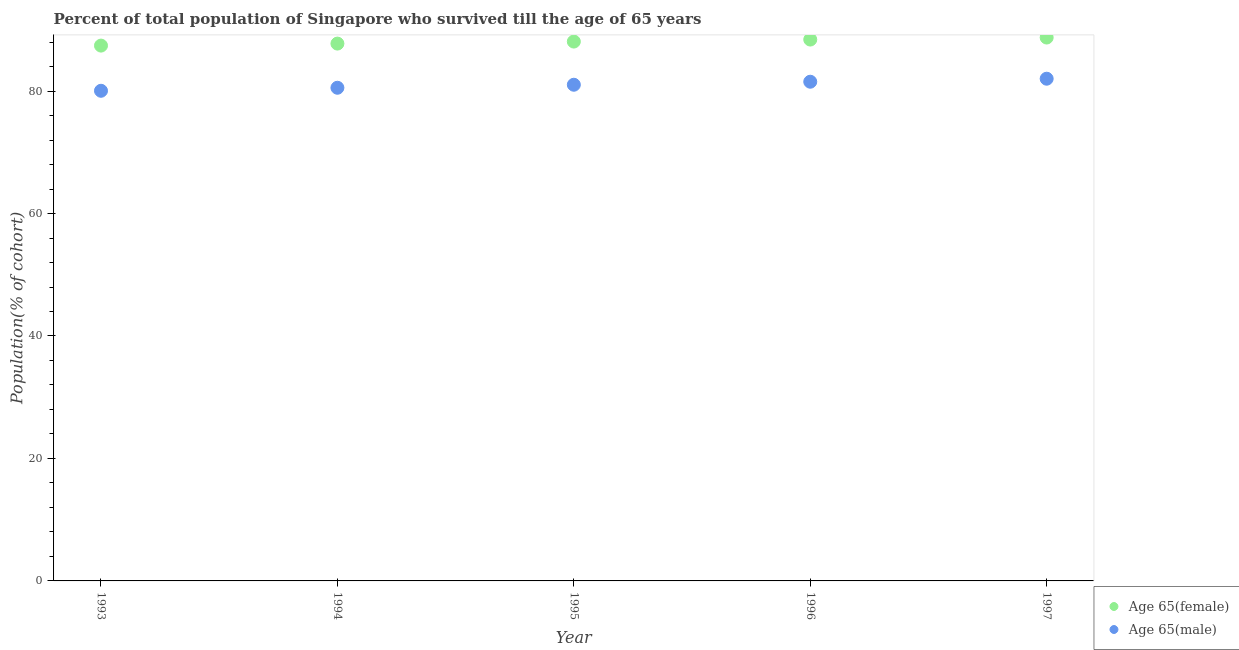How many different coloured dotlines are there?
Make the answer very short. 2. Is the number of dotlines equal to the number of legend labels?
Your answer should be compact. Yes. What is the percentage of female population who survived till age of 65 in 1993?
Offer a very short reply. 87.42. Across all years, what is the maximum percentage of male population who survived till age of 65?
Ensure brevity in your answer.  82.02. Across all years, what is the minimum percentage of male population who survived till age of 65?
Your response must be concise. 80.05. What is the total percentage of male population who survived till age of 65 in the graph?
Provide a short and direct response. 405.16. What is the difference between the percentage of female population who survived till age of 65 in 1996 and that in 1997?
Make the answer very short. -0.33. What is the difference between the percentage of female population who survived till age of 65 in 1997 and the percentage of male population who survived till age of 65 in 1996?
Give a very brief answer. 7.22. What is the average percentage of male population who survived till age of 65 per year?
Provide a succinct answer. 81.03. In the year 1993, what is the difference between the percentage of male population who survived till age of 65 and percentage of female population who survived till age of 65?
Keep it short and to the point. -7.38. What is the ratio of the percentage of male population who survived till age of 65 in 1995 to that in 1997?
Make the answer very short. 0.99. Is the difference between the percentage of female population who survived till age of 65 in 1993 and 1997 greater than the difference between the percentage of male population who survived till age of 65 in 1993 and 1997?
Keep it short and to the point. Yes. What is the difference between the highest and the second highest percentage of male population who survived till age of 65?
Offer a very short reply. 0.49. What is the difference between the highest and the lowest percentage of male population who survived till age of 65?
Keep it short and to the point. 1.97. Does the percentage of female population who survived till age of 65 monotonically increase over the years?
Your answer should be very brief. Yes. Is the percentage of female population who survived till age of 65 strictly less than the percentage of male population who survived till age of 65 over the years?
Ensure brevity in your answer.  No. How many dotlines are there?
Keep it short and to the point. 2. Does the graph contain grids?
Your response must be concise. No. How are the legend labels stacked?
Provide a succinct answer. Vertical. What is the title of the graph?
Provide a succinct answer. Percent of total population of Singapore who survived till the age of 65 years. What is the label or title of the Y-axis?
Your response must be concise. Population(% of cohort). What is the Population(% of cohort) of Age 65(female) in 1993?
Your answer should be very brief. 87.42. What is the Population(% of cohort) in Age 65(male) in 1993?
Ensure brevity in your answer.  80.05. What is the Population(% of cohort) in Age 65(female) in 1994?
Make the answer very short. 87.75. What is the Population(% of cohort) in Age 65(male) in 1994?
Make the answer very short. 80.54. What is the Population(% of cohort) of Age 65(female) in 1995?
Ensure brevity in your answer.  88.08. What is the Population(% of cohort) of Age 65(male) in 1995?
Give a very brief answer. 81.03. What is the Population(% of cohort) of Age 65(female) in 1996?
Your answer should be compact. 88.41. What is the Population(% of cohort) in Age 65(male) in 1996?
Offer a very short reply. 81.52. What is the Population(% of cohort) in Age 65(female) in 1997?
Offer a terse response. 88.74. What is the Population(% of cohort) of Age 65(male) in 1997?
Provide a succinct answer. 82.02. Across all years, what is the maximum Population(% of cohort) in Age 65(female)?
Provide a succinct answer. 88.74. Across all years, what is the maximum Population(% of cohort) of Age 65(male)?
Give a very brief answer. 82.02. Across all years, what is the minimum Population(% of cohort) in Age 65(female)?
Your answer should be very brief. 87.42. Across all years, what is the minimum Population(% of cohort) of Age 65(male)?
Your response must be concise. 80.05. What is the total Population(% of cohort) in Age 65(female) in the graph?
Provide a succinct answer. 440.41. What is the total Population(% of cohort) in Age 65(male) in the graph?
Offer a very short reply. 405.16. What is the difference between the Population(% of cohort) in Age 65(female) in 1993 and that in 1994?
Give a very brief answer. -0.33. What is the difference between the Population(% of cohort) in Age 65(male) in 1993 and that in 1994?
Offer a terse response. -0.49. What is the difference between the Population(% of cohort) in Age 65(female) in 1993 and that in 1995?
Offer a terse response. -0.66. What is the difference between the Population(% of cohort) of Age 65(male) in 1993 and that in 1995?
Make the answer very short. -0.99. What is the difference between the Population(% of cohort) in Age 65(female) in 1993 and that in 1996?
Keep it short and to the point. -0.99. What is the difference between the Population(% of cohort) of Age 65(male) in 1993 and that in 1996?
Give a very brief answer. -1.48. What is the difference between the Population(% of cohort) of Age 65(female) in 1993 and that in 1997?
Offer a terse response. -1.32. What is the difference between the Population(% of cohort) in Age 65(male) in 1993 and that in 1997?
Ensure brevity in your answer.  -1.97. What is the difference between the Population(% of cohort) of Age 65(female) in 1994 and that in 1995?
Your answer should be compact. -0.33. What is the difference between the Population(% of cohort) in Age 65(male) in 1994 and that in 1995?
Your answer should be compact. -0.49. What is the difference between the Population(% of cohort) in Age 65(female) in 1994 and that in 1996?
Your answer should be compact. -0.66. What is the difference between the Population(% of cohort) of Age 65(male) in 1994 and that in 1996?
Offer a terse response. -0.99. What is the difference between the Population(% of cohort) of Age 65(female) in 1994 and that in 1997?
Provide a short and direct response. -0.99. What is the difference between the Population(% of cohort) of Age 65(male) in 1994 and that in 1997?
Give a very brief answer. -1.48. What is the difference between the Population(% of cohort) of Age 65(female) in 1995 and that in 1996?
Keep it short and to the point. -0.33. What is the difference between the Population(% of cohort) of Age 65(male) in 1995 and that in 1996?
Offer a very short reply. -0.49. What is the difference between the Population(% of cohort) in Age 65(female) in 1995 and that in 1997?
Your answer should be compact. -0.66. What is the difference between the Population(% of cohort) in Age 65(male) in 1995 and that in 1997?
Provide a succinct answer. -0.99. What is the difference between the Population(% of cohort) in Age 65(female) in 1996 and that in 1997?
Offer a terse response. -0.33. What is the difference between the Population(% of cohort) in Age 65(male) in 1996 and that in 1997?
Your answer should be compact. -0.49. What is the difference between the Population(% of cohort) in Age 65(female) in 1993 and the Population(% of cohort) in Age 65(male) in 1994?
Offer a terse response. 6.89. What is the difference between the Population(% of cohort) in Age 65(female) in 1993 and the Population(% of cohort) in Age 65(male) in 1995?
Offer a very short reply. 6.39. What is the difference between the Population(% of cohort) of Age 65(female) in 1993 and the Population(% of cohort) of Age 65(male) in 1997?
Your answer should be compact. 5.41. What is the difference between the Population(% of cohort) in Age 65(female) in 1994 and the Population(% of cohort) in Age 65(male) in 1995?
Your answer should be very brief. 6.72. What is the difference between the Population(% of cohort) in Age 65(female) in 1994 and the Population(% of cohort) in Age 65(male) in 1996?
Provide a short and direct response. 6.23. What is the difference between the Population(% of cohort) of Age 65(female) in 1994 and the Population(% of cohort) of Age 65(male) in 1997?
Offer a terse response. 5.74. What is the difference between the Population(% of cohort) of Age 65(female) in 1995 and the Population(% of cohort) of Age 65(male) in 1996?
Keep it short and to the point. 6.56. What is the difference between the Population(% of cohort) in Age 65(female) in 1995 and the Population(% of cohort) in Age 65(male) in 1997?
Provide a short and direct response. 6.07. What is the difference between the Population(% of cohort) of Age 65(female) in 1996 and the Population(% of cohort) of Age 65(male) in 1997?
Make the answer very short. 6.39. What is the average Population(% of cohort) in Age 65(female) per year?
Provide a succinct answer. 88.08. What is the average Population(% of cohort) of Age 65(male) per year?
Offer a very short reply. 81.03. In the year 1993, what is the difference between the Population(% of cohort) in Age 65(female) and Population(% of cohort) in Age 65(male)?
Offer a very short reply. 7.38. In the year 1994, what is the difference between the Population(% of cohort) of Age 65(female) and Population(% of cohort) of Age 65(male)?
Provide a short and direct response. 7.21. In the year 1995, what is the difference between the Population(% of cohort) of Age 65(female) and Population(% of cohort) of Age 65(male)?
Your answer should be very brief. 7.05. In the year 1996, what is the difference between the Population(% of cohort) in Age 65(female) and Population(% of cohort) in Age 65(male)?
Your answer should be very brief. 6.89. In the year 1997, what is the difference between the Population(% of cohort) of Age 65(female) and Population(% of cohort) of Age 65(male)?
Offer a terse response. 6.72. What is the ratio of the Population(% of cohort) of Age 65(female) in 1993 to that in 1994?
Offer a terse response. 1. What is the ratio of the Population(% of cohort) of Age 65(male) in 1993 to that in 1994?
Offer a terse response. 0.99. What is the ratio of the Population(% of cohort) of Age 65(female) in 1993 to that in 1995?
Give a very brief answer. 0.99. What is the ratio of the Population(% of cohort) of Age 65(male) in 1993 to that in 1996?
Offer a very short reply. 0.98. What is the ratio of the Population(% of cohort) in Age 65(female) in 1993 to that in 1997?
Your answer should be very brief. 0.99. What is the ratio of the Population(% of cohort) of Age 65(male) in 1993 to that in 1997?
Offer a very short reply. 0.98. What is the ratio of the Population(% of cohort) in Age 65(female) in 1994 to that in 1996?
Give a very brief answer. 0.99. What is the ratio of the Population(% of cohort) in Age 65(male) in 1994 to that in 1996?
Your response must be concise. 0.99. What is the ratio of the Population(% of cohort) in Age 65(female) in 1994 to that in 1997?
Ensure brevity in your answer.  0.99. What is the ratio of the Population(% of cohort) of Age 65(male) in 1994 to that in 1997?
Offer a terse response. 0.98. What is the ratio of the Population(% of cohort) of Age 65(female) in 1995 to that in 1996?
Give a very brief answer. 1. What is the ratio of the Population(% of cohort) in Age 65(male) in 1995 to that in 1996?
Your answer should be compact. 0.99. What is the ratio of the Population(% of cohort) of Age 65(male) in 1996 to that in 1997?
Offer a terse response. 0.99. What is the difference between the highest and the second highest Population(% of cohort) in Age 65(female)?
Your answer should be very brief. 0.33. What is the difference between the highest and the second highest Population(% of cohort) in Age 65(male)?
Your response must be concise. 0.49. What is the difference between the highest and the lowest Population(% of cohort) of Age 65(female)?
Offer a terse response. 1.32. What is the difference between the highest and the lowest Population(% of cohort) in Age 65(male)?
Ensure brevity in your answer.  1.97. 